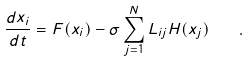<formula> <loc_0><loc_0><loc_500><loc_500>\frac { d { x } _ { i } } { d t } = { F } ( { x } _ { i } ) - \sigma \sum _ { j = 1 } ^ { N } L _ { i j } { H } ( { x } _ { j } ) \quad .</formula> 